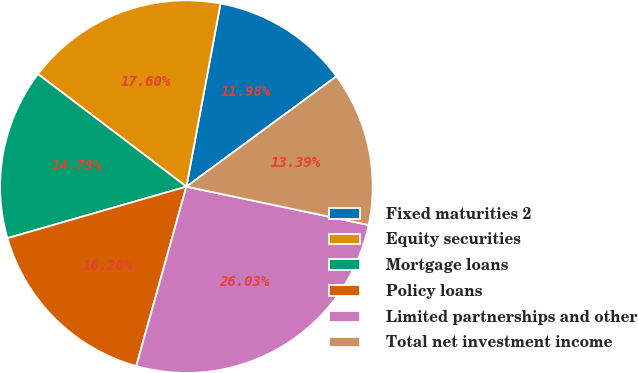<chart> <loc_0><loc_0><loc_500><loc_500><pie_chart><fcel>Fixed maturities 2<fcel>Equity securities<fcel>Mortgage loans<fcel>Policy loans<fcel>Limited partnerships and other<fcel>Total net investment income<nl><fcel>11.98%<fcel>17.6%<fcel>14.79%<fcel>16.2%<fcel>26.03%<fcel>13.39%<nl></chart> 